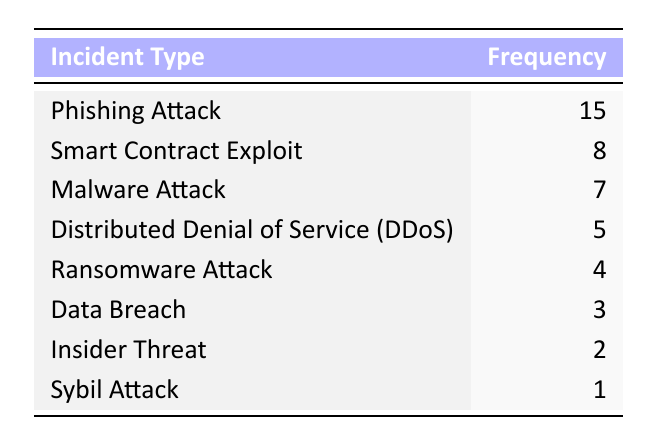What is the incident type with the highest frequency? By examining the frequency column in the table, the highest number listed is 15, which corresponds to the incident type "Phishing Attack."
Answer: Phishing Attack How many incidents were reported for Smart Contract Exploit and Malware Attack combined? The frequency for Smart Contract Exploit is 8 and for Malware Attack is 7. If we add them together (8 + 7), we get 15 incidents combined.
Answer: 15 Is the frequency of Data Breach less than that of Ransomware Attack? The frequency for Data Breach is 3 and for Ransomware Attack is 4. Since 3 is less than 4, the statement is true.
Answer: Yes What are the total frequency counts of all reported incidents? We need to sum the frequency of each incident type: 15 + 8 + 7 + 5 + 4 + 3 + 2 + 1 = 45. Thus, the total frequency of all incidents is 45.
Answer: 45 What is the median frequency of reported security incidents? First, we list the frequencies in order: 1, 2, 3, 4, 5, 7, 8, 15. There are 8 values, so the median will be the average of the 4th and 5th values: (4 + 5) / 2 = 4.5.
Answer: 4.5 